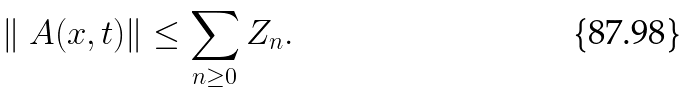Convert formula to latex. <formula><loc_0><loc_0><loc_500><loc_500>\| \ A ( x , t ) \| \leq \sum _ { n \geq 0 } Z _ { n } .</formula> 